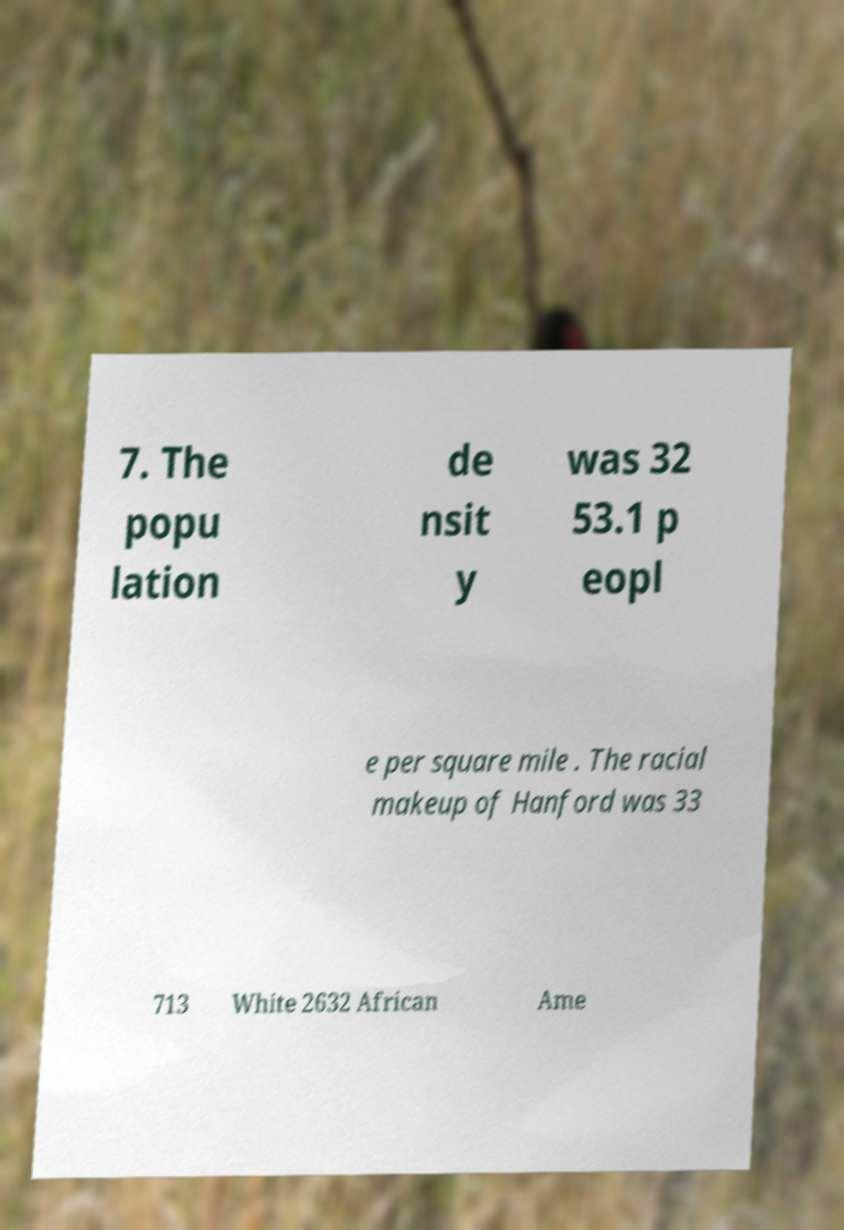Could you extract and type out the text from this image? 7. The popu lation de nsit y was 32 53.1 p eopl e per square mile . The racial makeup of Hanford was 33 713 White 2632 African Ame 